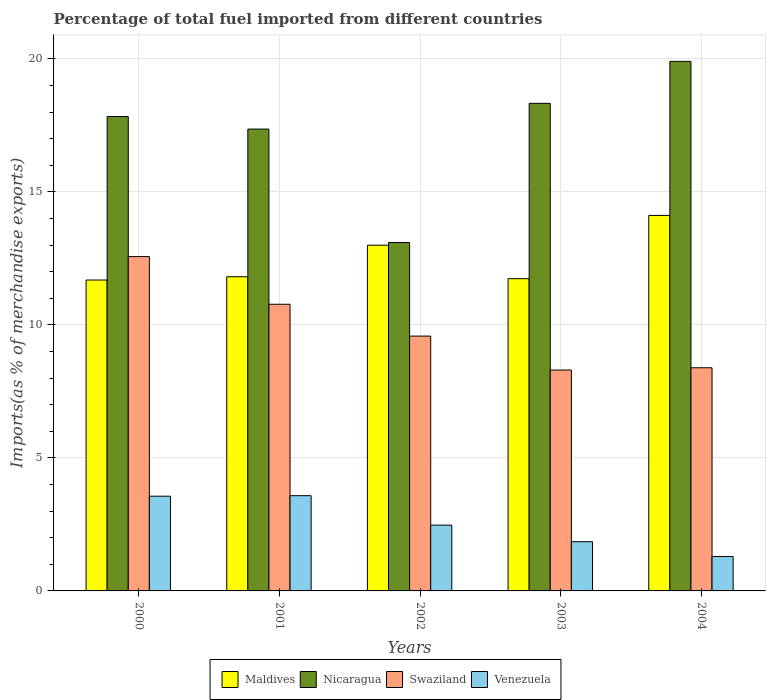How many groups of bars are there?
Your answer should be compact. 5. Are the number of bars per tick equal to the number of legend labels?
Provide a succinct answer. Yes. What is the label of the 1st group of bars from the left?
Your response must be concise. 2000. In how many cases, is the number of bars for a given year not equal to the number of legend labels?
Make the answer very short. 0. What is the percentage of imports to different countries in Nicaragua in 2003?
Offer a terse response. 18.33. Across all years, what is the maximum percentage of imports to different countries in Maldives?
Your answer should be very brief. 14.11. Across all years, what is the minimum percentage of imports to different countries in Nicaragua?
Provide a short and direct response. 13.1. In which year was the percentage of imports to different countries in Nicaragua maximum?
Offer a very short reply. 2004. In which year was the percentage of imports to different countries in Swaziland minimum?
Your answer should be compact. 2003. What is the total percentage of imports to different countries in Swaziland in the graph?
Your answer should be very brief. 49.61. What is the difference between the percentage of imports to different countries in Maldives in 2000 and that in 2001?
Keep it short and to the point. -0.12. What is the difference between the percentage of imports to different countries in Nicaragua in 2000 and the percentage of imports to different countries in Venezuela in 2003?
Make the answer very short. 15.98. What is the average percentage of imports to different countries in Venezuela per year?
Provide a succinct answer. 2.55. In the year 2000, what is the difference between the percentage of imports to different countries in Maldives and percentage of imports to different countries in Nicaragua?
Provide a short and direct response. -6.14. What is the ratio of the percentage of imports to different countries in Maldives in 2000 to that in 2001?
Your answer should be very brief. 0.99. Is the percentage of imports to different countries in Nicaragua in 2001 less than that in 2002?
Your answer should be compact. No. Is the difference between the percentage of imports to different countries in Maldives in 2000 and 2001 greater than the difference between the percentage of imports to different countries in Nicaragua in 2000 and 2001?
Provide a succinct answer. No. What is the difference between the highest and the second highest percentage of imports to different countries in Venezuela?
Provide a short and direct response. 0.02. What is the difference between the highest and the lowest percentage of imports to different countries in Swaziland?
Your answer should be compact. 4.26. In how many years, is the percentage of imports to different countries in Venezuela greater than the average percentage of imports to different countries in Venezuela taken over all years?
Your answer should be compact. 2. Is the sum of the percentage of imports to different countries in Nicaragua in 2000 and 2001 greater than the maximum percentage of imports to different countries in Venezuela across all years?
Provide a succinct answer. Yes. Is it the case that in every year, the sum of the percentage of imports to different countries in Venezuela and percentage of imports to different countries in Maldives is greater than the sum of percentage of imports to different countries in Nicaragua and percentage of imports to different countries in Swaziland?
Give a very brief answer. No. What does the 4th bar from the left in 2004 represents?
Provide a short and direct response. Venezuela. What does the 4th bar from the right in 2002 represents?
Your answer should be very brief. Maldives. What is the difference between two consecutive major ticks on the Y-axis?
Offer a very short reply. 5. Are the values on the major ticks of Y-axis written in scientific E-notation?
Ensure brevity in your answer.  No. Does the graph contain any zero values?
Your response must be concise. No. How many legend labels are there?
Give a very brief answer. 4. How are the legend labels stacked?
Your response must be concise. Horizontal. What is the title of the graph?
Keep it short and to the point. Percentage of total fuel imported from different countries. What is the label or title of the X-axis?
Your answer should be compact. Years. What is the label or title of the Y-axis?
Your response must be concise. Imports(as % of merchandise exports). What is the Imports(as % of merchandise exports) of Maldives in 2000?
Make the answer very short. 11.69. What is the Imports(as % of merchandise exports) of Nicaragua in 2000?
Ensure brevity in your answer.  17.83. What is the Imports(as % of merchandise exports) of Swaziland in 2000?
Make the answer very short. 12.57. What is the Imports(as % of merchandise exports) in Venezuela in 2000?
Provide a short and direct response. 3.56. What is the Imports(as % of merchandise exports) in Maldives in 2001?
Make the answer very short. 11.81. What is the Imports(as % of merchandise exports) in Nicaragua in 2001?
Your answer should be very brief. 17.36. What is the Imports(as % of merchandise exports) of Swaziland in 2001?
Provide a succinct answer. 10.78. What is the Imports(as % of merchandise exports) of Venezuela in 2001?
Ensure brevity in your answer.  3.58. What is the Imports(as % of merchandise exports) of Maldives in 2002?
Keep it short and to the point. 13. What is the Imports(as % of merchandise exports) of Nicaragua in 2002?
Provide a succinct answer. 13.1. What is the Imports(as % of merchandise exports) in Swaziland in 2002?
Provide a short and direct response. 9.58. What is the Imports(as % of merchandise exports) in Venezuela in 2002?
Your answer should be very brief. 2.47. What is the Imports(as % of merchandise exports) in Maldives in 2003?
Provide a succinct answer. 11.74. What is the Imports(as % of merchandise exports) in Nicaragua in 2003?
Make the answer very short. 18.33. What is the Imports(as % of merchandise exports) in Swaziland in 2003?
Your answer should be very brief. 8.3. What is the Imports(as % of merchandise exports) of Venezuela in 2003?
Keep it short and to the point. 1.85. What is the Imports(as % of merchandise exports) in Maldives in 2004?
Your response must be concise. 14.11. What is the Imports(as % of merchandise exports) of Nicaragua in 2004?
Make the answer very short. 19.91. What is the Imports(as % of merchandise exports) in Swaziland in 2004?
Your answer should be very brief. 8.39. What is the Imports(as % of merchandise exports) in Venezuela in 2004?
Ensure brevity in your answer.  1.29. Across all years, what is the maximum Imports(as % of merchandise exports) in Maldives?
Your response must be concise. 14.11. Across all years, what is the maximum Imports(as % of merchandise exports) in Nicaragua?
Make the answer very short. 19.91. Across all years, what is the maximum Imports(as % of merchandise exports) in Swaziland?
Give a very brief answer. 12.57. Across all years, what is the maximum Imports(as % of merchandise exports) of Venezuela?
Make the answer very short. 3.58. Across all years, what is the minimum Imports(as % of merchandise exports) in Maldives?
Keep it short and to the point. 11.69. Across all years, what is the minimum Imports(as % of merchandise exports) of Nicaragua?
Ensure brevity in your answer.  13.1. Across all years, what is the minimum Imports(as % of merchandise exports) of Swaziland?
Offer a terse response. 8.3. Across all years, what is the minimum Imports(as % of merchandise exports) of Venezuela?
Make the answer very short. 1.29. What is the total Imports(as % of merchandise exports) in Maldives in the graph?
Your answer should be very brief. 62.34. What is the total Imports(as % of merchandise exports) of Nicaragua in the graph?
Your answer should be compact. 86.52. What is the total Imports(as % of merchandise exports) of Swaziland in the graph?
Your answer should be very brief. 49.61. What is the total Imports(as % of merchandise exports) of Venezuela in the graph?
Provide a succinct answer. 12.76. What is the difference between the Imports(as % of merchandise exports) in Maldives in 2000 and that in 2001?
Your answer should be compact. -0.12. What is the difference between the Imports(as % of merchandise exports) in Nicaragua in 2000 and that in 2001?
Ensure brevity in your answer.  0.47. What is the difference between the Imports(as % of merchandise exports) of Swaziland in 2000 and that in 2001?
Ensure brevity in your answer.  1.79. What is the difference between the Imports(as % of merchandise exports) of Venezuela in 2000 and that in 2001?
Keep it short and to the point. -0.02. What is the difference between the Imports(as % of merchandise exports) of Maldives in 2000 and that in 2002?
Provide a short and direct response. -1.31. What is the difference between the Imports(as % of merchandise exports) in Nicaragua in 2000 and that in 2002?
Your answer should be very brief. 4.73. What is the difference between the Imports(as % of merchandise exports) of Swaziland in 2000 and that in 2002?
Offer a terse response. 2.99. What is the difference between the Imports(as % of merchandise exports) of Venezuela in 2000 and that in 2002?
Give a very brief answer. 1.09. What is the difference between the Imports(as % of merchandise exports) of Maldives in 2000 and that in 2003?
Provide a succinct answer. -0.05. What is the difference between the Imports(as % of merchandise exports) of Nicaragua in 2000 and that in 2003?
Ensure brevity in your answer.  -0.5. What is the difference between the Imports(as % of merchandise exports) in Swaziland in 2000 and that in 2003?
Offer a terse response. 4.26. What is the difference between the Imports(as % of merchandise exports) of Venezuela in 2000 and that in 2003?
Provide a short and direct response. 1.71. What is the difference between the Imports(as % of merchandise exports) in Maldives in 2000 and that in 2004?
Give a very brief answer. -2.43. What is the difference between the Imports(as % of merchandise exports) of Nicaragua in 2000 and that in 2004?
Ensure brevity in your answer.  -2.08. What is the difference between the Imports(as % of merchandise exports) in Swaziland in 2000 and that in 2004?
Make the answer very short. 4.18. What is the difference between the Imports(as % of merchandise exports) of Venezuela in 2000 and that in 2004?
Your response must be concise. 2.27. What is the difference between the Imports(as % of merchandise exports) of Maldives in 2001 and that in 2002?
Your response must be concise. -1.19. What is the difference between the Imports(as % of merchandise exports) in Nicaragua in 2001 and that in 2002?
Your answer should be compact. 4.26. What is the difference between the Imports(as % of merchandise exports) in Swaziland in 2001 and that in 2002?
Ensure brevity in your answer.  1.2. What is the difference between the Imports(as % of merchandise exports) of Venezuela in 2001 and that in 2002?
Your answer should be very brief. 1.11. What is the difference between the Imports(as % of merchandise exports) in Maldives in 2001 and that in 2003?
Provide a short and direct response. 0.07. What is the difference between the Imports(as % of merchandise exports) of Nicaragua in 2001 and that in 2003?
Your answer should be compact. -0.97. What is the difference between the Imports(as % of merchandise exports) in Swaziland in 2001 and that in 2003?
Give a very brief answer. 2.47. What is the difference between the Imports(as % of merchandise exports) in Venezuela in 2001 and that in 2003?
Offer a terse response. 1.73. What is the difference between the Imports(as % of merchandise exports) of Maldives in 2001 and that in 2004?
Provide a short and direct response. -2.3. What is the difference between the Imports(as % of merchandise exports) in Nicaragua in 2001 and that in 2004?
Provide a succinct answer. -2.55. What is the difference between the Imports(as % of merchandise exports) of Swaziland in 2001 and that in 2004?
Make the answer very short. 2.39. What is the difference between the Imports(as % of merchandise exports) of Venezuela in 2001 and that in 2004?
Your answer should be very brief. 2.29. What is the difference between the Imports(as % of merchandise exports) of Maldives in 2002 and that in 2003?
Ensure brevity in your answer.  1.26. What is the difference between the Imports(as % of merchandise exports) in Nicaragua in 2002 and that in 2003?
Your answer should be compact. -5.23. What is the difference between the Imports(as % of merchandise exports) of Swaziland in 2002 and that in 2003?
Make the answer very short. 1.28. What is the difference between the Imports(as % of merchandise exports) in Venezuela in 2002 and that in 2003?
Give a very brief answer. 0.62. What is the difference between the Imports(as % of merchandise exports) in Maldives in 2002 and that in 2004?
Offer a terse response. -1.12. What is the difference between the Imports(as % of merchandise exports) of Nicaragua in 2002 and that in 2004?
Keep it short and to the point. -6.81. What is the difference between the Imports(as % of merchandise exports) of Swaziland in 2002 and that in 2004?
Your answer should be very brief. 1.19. What is the difference between the Imports(as % of merchandise exports) of Venezuela in 2002 and that in 2004?
Ensure brevity in your answer.  1.18. What is the difference between the Imports(as % of merchandise exports) in Maldives in 2003 and that in 2004?
Ensure brevity in your answer.  -2.38. What is the difference between the Imports(as % of merchandise exports) in Nicaragua in 2003 and that in 2004?
Your answer should be compact. -1.58. What is the difference between the Imports(as % of merchandise exports) of Swaziland in 2003 and that in 2004?
Offer a terse response. -0.09. What is the difference between the Imports(as % of merchandise exports) in Venezuela in 2003 and that in 2004?
Make the answer very short. 0.56. What is the difference between the Imports(as % of merchandise exports) of Maldives in 2000 and the Imports(as % of merchandise exports) of Nicaragua in 2001?
Keep it short and to the point. -5.67. What is the difference between the Imports(as % of merchandise exports) in Maldives in 2000 and the Imports(as % of merchandise exports) in Swaziland in 2001?
Provide a succinct answer. 0.91. What is the difference between the Imports(as % of merchandise exports) in Maldives in 2000 and the Imports(as % of merchandise exports) in Venezuela in 2001?
Your answer should be compact. 8.11. What is the difference between the Imports(as % of merchandise exports) in Nicaragua in 2000 and the Imports(as % of merchandise exports) in Swaziland in 2001?
Give a very brief answer. 7.06. What is the difference between the Imports(as % of merchandise exports) in Nicaragua in 2000 and the Imports(as % of merchandise exports) in Venezuela in 2001?
Provide a succinct answer. 14.25. What is the difference between the Imports(as % of merchandise exports) of Swaziland in 2000 and the Imports(as % of merchandise exports) of Venezuela in 2001?
Provide a short and direct response. 8.99. What is the difference between the Imports(as % of merchandise exports) of Maldives in 2000 and the Imports(as % of merchandise exports) of Nicaragua in 2002?
Keep it short and to the point. -1.41. What is the difference between the Imports(as % of merchandise exports) of Maldives in 2000 and the Imports(as % of merchandise exports) of Swaziland in 2002?
Your answer should be very brief. 2.11. What is the difference between the Imports(as % of merchandise exports) of Maldives in 2000 and the Imports(as % of merchandise exports) of Venezuela in 2002?
Your answer should be compact. 9.21. What is the difference between the Imports(as % of merchandise exports) in Nicaragua in 2000 and the Imports(as % of merchandise exports) in Swaziland in 2002?
Give a very brief answer. 8.25. What is the difference between the Imports(as % of merchandise exports) in Nicaragua in 2000 and the Imports(as % of merchandise exports) in Venezuela in 2002?
Make the answer very short. 15.36. What is the difference between the Imports(as % of merchandise exports) of Swaziland in 2000 and the Imports(as % of merchandise exports) of Venezuela in 2002?
Your response must be concise. 10.09. What is the difference between the Imports(as % of merchandise exports) in Maldives in 2000 and the Imports(as % of merchandise exports) in Nicaragua in 2003?
Make the answer very short. -6.64. What is the difference between the Imports(as % of merchandise exports) in Maldives in 2000 and the Imports(as % of merchandise exports) in Swaziland in 2003?
Provide a short and direct response. 3.38. What is the difference between the Imports(as % of merchandise exports) of Maldives in 2000 and the Imports(as % of merchandise exports) of Venezuela in 2003?
Provide a succinct answer. 9.84. What is the difference between the Imports(as % of merchandise exports) in Nicaragua in 2000 and the Imports(as % of merchandise exports) in Swaziland in 2003?
Offer a terse response. 9.53. What is the difference between the Imports(as % of merchandise exports) of Nicaragua in 2000 and the Imports(as % of merchandise exports) of Venezuela in 2003?
Make the answer very short. 15.98. What is the difference between the Imports(as % of merchandise exports) in Swaziland in 2000 and the Imports(as % of merchandise exports) in Venezuela in 2003?
Offer a very short reply. 10.72. What is the difference between the Imports(as % of merchandise exports) of Maldives in 2000 and the Imports(as % of merchandise exports) of Nicaragua in 2004?
Your answer should be very brief. -8.22. What is the difference between the Imports(as % of merchandise exports) of Maldives in 2000 and the Imports(as % of merchandise exports) of Swaziland in 2004?
Make the answer very short. 3.3. What is the difference between the Imports(as % of merchandise exports) in Maldives in 2000 and the Imports(as % of merchandise exports) in Venezuela in 2004?
Provide a short and direct response. 10.39. What is the difference between the Imports(as % of merchandise exports) in Nicaragua in 2000 and the Imports(as % of merchandise exports) in Swaziland in 2004?
Offer a very short reply. 9.44. What is the difference between the Imports(as % of merchandise exports) of Nicaragua in 2000 and the Imports(as % of merchandise exports) of Venezuela in 2004?
Ensure brevity in your answer.  16.54. What is the difference between the Imports(as % of merchandise exports) of Swaziland in 2000 and the Imports(as % of merchandise exports) of Venezuela in 2004?
Keep it short and to the point. 11.27. What is the difference between the Imports(as % of merchandise exports) of Maldives in 2001 and the Imports(as % of merchandise exports) of Nicaragua in 2002?
Give a very brief answer. -1.29. What is the difference between the Imports(as % of merchandise exports) in Maldives in 2001 and the Imports(as % of merchandise exports) in Swaziland in 2002?
Keep it short and to the point. 2.23. What is the difference between the Imports(as % of merchandise exports) in Maldives in 2001 and the Imports(as % of merchandise exports) in Venezuela in 2002?
Ensure brevity in your answer.  9.34. What is the difference between the Imports(as % of merchandise exports) in Nicaragua in 2001 and the Imports(as % of merchandise exports) in Swaziland in 2002?
Provide a succinct answer. 7.78. What is the difference between the Imports(as % of merchandise exports) of Nicaragua in 2001 and the Imports(as % of merchandise exports) of Venezuela in 2002?
Your response must be concise. 14.89. What is the difference between the Imports(as % of merchandise exports) of Swaziland in 2001 and the Imports(as % of merchandise exports) of Venezuela in 2002?
Keep it short and to the point. 8.3. What is the difference between the Imports(as % of merchandise exports) in Maldives in 2001 and the Imports(as % of merchandise exports) in Nicaragua in 2003?
Offer a very short reply. -6.52. What is the difference between the Imports(as % of merchandise exports) in Maldives in 2001 and the Imports(as % of merchandise exports) in Swaziland in 2003?
Keep it short and to the point. 3.51. What is the difference between the Imports(as % of merchandise exports) of Maldives in 2001 and the Imports(as % of merchandise exports) of Venezuela in 2003?
Your answer should be compact. 9.96. What is the difference between the Imports(as % of merchandise exports) in Nicaragua in 2001 and the Imports(as % of merchandise exports) in Swaziland in 2003?
Keep it short and to the point. 9.06. What is the difference between the Imports(as % of merchandise exports) of Nicaragua in 2001 and the Imports(as % of merchandise exports) of Venezuela in 2003?
Your answer should be compact. 15.51. What is the difference between the Imports(as % of merchandise exports) in Swaziland in 2001 and the Imports(as % of merchandise exports) in Venezuela in 2003?
Your response must be concise. 8.93. What is the difference between the Imports(as % of merchandise exports) of Maldives in 2001 and the Imports(as % of merchandise exports) of Nicaragua in 2004?
Ensure brevity in your answer.  -8.1. What is the difference between the Imports(as % of merchandise exports) in Maldives in 2001 and the Imports(as % of merchandise exports) in Swaziland in 2004?
Offer a very short reply. 3.42. What is the difference between the Imports(as % of merchandise exports) in Maldives in 2001 and the Imports(as % of merchandise exports) in Venezuela in 2004?
Ensure brevity in your answer.  10.52. What is the difference between the Imports(as % of merchandise exports) of Nicaragua in 2001 and the Imports(as % of merchandise exports) of Swaziland in 2004?
Provide a short and direct response. 8.97. What is the difference between the Imports(as % of merchandise exports) in Nicaragua in 2001 and the Imports(as % of merchandise exports) in Venezuela in 2004?
Provide a succinct answer. 16.07. What is the difference between the Imports(as % of merchandise exports) in Swaziland in 2001 and the Imports(as % of merchandise exports) in Venezuela in 2004?
Make the answer very short. 9.48. What is the difference between the Imports(as % of merchandise exports) in Maldives in 2002 and the Imports(as % of merchandise exports) in Nicaragua in 2003?
Your response must be concise. -5.33. What is the difference between the Imports(as % of merchandise exports) of Maldives in 2002 and the Imports(as % of merchandise exports) of Swaziland in 2003?
Keep it short and to the point. 4.69. What is the difference between the Imports(as % of merchandise exports) of Maldives in 2002 and the Imports(as % of merchandise exports) of Venezuela in 2003?
Offer a terse response. 11.15. What is the difference between the Imports(as % of merchandise exports) in Nicaragua in 2002 and the Imports(as % of merchandise exports) in Swaziland in 2003?
Make the answer very short. 4.79. What is the difference between the Imports(as % of merchandise exports) in Nicaragua in 2002 and the Imports(as % of merchandise exports) in Venezuela in 2003?
Keep it short and to the point. 11.25. What is the difference between the Imports(as % of merchandise exports) in Swaziland in 2002 and the Imports(as % of merchandise exports) in Venezuela in 2003?
Keep it short and to the point. 7.73. What is the difference between the Imports(as % of merchandise exports) of Maldives in 2002 and the Imports(as % of merchandise exports) of Nicaragua in 2004?
Provide a succinct answer. -6.91. What is the difference between the Imports(as % of merchandise exports) in Maldives in 2002 and the Imports(as % of merchandise exports) in Swaziland in 2004?
Ensure brevity in your answer.  4.61. What is the difference between the Imports(as % of merchandise exports) in Maldives in 2002 and the Imports(as % of merchandise exports) in Venezuela in 2004?
Provide a succinct answer. 11.7. What is the difference between the Imports(as % of merchandise exports) of Nicaragua in 2002 and the Imports(as % of merchandise exports) of Swaziland in 2004?
Your response must be concise. 4.71. What is the difference between the Imports(as % of merchandise exports) in Nicaragua in 2002 and the Imports(as % of merchandise exports) in Venezuela in 2004?
Offer a terse response. 11.8. What is the difference between the Imports(as % of merchandise exports) of Swaziland in 2002 and the Imports(as % of merchandise exports) of Venezuela in 2004?
Provide a short and direct response. 8.29. What is the difference between the Imports(as % of merchandise exports) of Maldives in 2003 and the Imports(as % of merchandise exports) of Nicaragua in 2004?
Your answer should be very brief. -8.17. What is the difference between the Imports(as % of merchandise exports) in Maldives in 2003 and the Imports(as % of merchandise exports) in Swaziland in 2004?
Provide a succinct answer. 3.35. What is the difference between the Imports(as % of merchandise exports) of Maldives in 2003 and the Imports(as % of merchandise exports) of Venezuela in 2004?
Keep it short and to the point. 10.44. What is the difference between the Imports(as % of merchandise exports) of Nicaragua in 2003 and the Imports(as % of merchandise exports) of Swaziland in 2004?
Provide a short and direct response. 9.94. What is the difference between the Imports(as % of merchandise exports) of Nicaragua in 2003 and the Imports(as % of merchandise exports) of Venezuela in 2004?
Keep it short and to the point. 17.03. What is the difference between the Imports(as % of merchandise exports) of Swaziland in 2003 and the Imports(as % of merchandise exports) of Venezuela in 2004?
Your response must be concise. 7.01. What is the average Imports(as % of merchandise exports) in Maldives per year?
Your response must be concise. 12.47. What is the average Imports(as % of merchandise exports) of Nicaragua per year?
Your answer should be compact. 17.3. What is the average Imports(as % of merchandise exports) of Swaziland per year?
Offer a terse response. 9.92. What is the average Imports(as % of merchandise exports) in Venezuela per year?
Offer a very short reply. 2.55. In the year 2000, what is the difference between the Imports(as % of merchandise exports) of Maldives and Imports(as % of merchandise exports) of Nicaragua?
Make the answer very short. -6.14. In the year 2000, what is the difference between the Imports(as % of merchandise exports) of Maldives and Imports(as % of merchandise exports) of Swaziland?
Your answer should be compact. -0.88. In the year 2000, what is the difference between the Imports(as % of merchandise exports) in Maldives and Imports(as % of merchandise exports) in Venezuela?
Provide a short and direct response. 8.13. In the year 2000, what is the difference between the Imports(as % of merchandise exports) of Nicaragua and Imports(as % of merchandise exports) of Swaziland?
Offer a very short reply. 5.26. In the year 2000, what is the difference between the Imports(as % of merchandise exports) in Nicaragua and Imports(as % of merchandise exports) in Venezuela?
Your answer should be very brief. 14.27. In the year 2000, what is the difference between the Imports(as % of merchandise exports) in Swaziland and Imports(as % of merchandise exports) in Venezuela?
Offer a very short reply. 9.01. In the year 2001, what is the difference between the Imports(as % of merchandise exports) in Maldives and Imports(as % of merchandise exports) in Nicaragua?
Provide a succinct answer. -5.55. In the year 2001, what is the difference between the Imports(as % of merchandise exports) of Maldives and Imports(as % of merchandise exports) of Swaziland?
Offer a terse response. 1.03. In the year 2001, what is the difference between the Imports(as % of merchandise exports) of Maldives and Imports(as % of merchandise exports) of Venezuela?
Provide a succinct answer. 8.23. In the year 2001, what is the difference between the Imports(as % of merchandise exports) of Nicaragua and Imports(as % of merchandise exports) of Swaziland?
Keep it short and to the point. 6.58. In the year 2001, what is the difference between the Imports(as % of merchandise exports) of Nicaragua and Imports(as % of merchandise exports) of Venezuela?
Provide a short and direct response. 13.78. In the year 2001, what is the difference between the Imports(as % of merchandise exports) of Swaziland and Imports(as % of merchandise exports) of Venezuela?
Give a very brief answer. 7.2. In the year 2002, what is the difference between the Imports(as % of merchandise exports) of Maldives and Imports(as % of merchandise exports) of Nicaragua?
Your answer should be compact. -0.1. In the year 2002, what is the difference between the Imports(as % of merchandise exports) of Maldives and Imports(as % of merchandise exports) of Swaziland?
Make the answer very short. 3.42. In the year 2002, what is the difference between the Imports(as % of merchandise exports) in Maldives and Imports(as % of merchandise exports) in Venezuela?
Your answer should be very brief. 10.52. In the year 2002, what is the difference between the Imports(as % of merchandise exports) in Nicaragua and Imports(as % of merchandise exports) in Swaziland?
Provide a succinct answer. 3.52. In the year 2002, what is the difference between the Imports(as % of merchandise exports) in Nicaragua and Imports(as % of merchandise exports) in Venezuela?
Provide a succinct answer. 10.62. In the year 2002, what is the difference between the Imports(as % of merchandise exports) of Swaziland and Imports(as % of merchandise exports) of Venezuela?
Ensure brevity in your answer.  7.11. In the year 2003, what is the difference between the Imports(as % of merchandise exports) in Maldives and Imports(as % of merchandise exports) in Nicaragua?
Make the answer very short. -6.59. In the year 2003, what is the difference between the Imports(as % of merchandise exports) in Maldives and Imports(as % of merchandise exports) in Swaziland?
Give a very brief answer. 3.43. In the year 2003, what is the difference between the Imports(as % of merchandise exports) of Maldives and Imports(as % of merchandise exports) of Venezuela?
Provide a short and direct response. 9.89. In the year 2003, what is the difference between the Imports(as % of merchandise exports) of Nicaragua and Imports(as % of merchandise exports) of Swaziland?
Provide a succinct answer. 10.02. In the year 2003, what is the difference between the Imports(as % of merchandise exports) in Nicaragua and Imports(as % of merchandise exports) in Venezuela?
Give a very brief answer. 16.48. In the year 2003, what is the difference between the Imports(as % of merchandise exports) in Swaziland and Imports(as % of merchandise exports) in Venezuela?
Your response must be concise. 6.45. In the year 2004, what is the difference between the Imports(as % of merchandise exports) of Maldives and Imports(as % of merchandise exports) of Nicaragua?
Make the answer very short. -5.79. In the year 2004, what is the difference between the Imports(as % of merchandise exports) in Maldives and Imports(as % of merchandise exports) in Swaziland?
Make the answer very short. 5.73. In the year 2004, what is the difference between the Imports(as % of merchandise exports) of Maldives and Imports(as % of merchandise exports) of Venezuela?
Your answer should be compact. 12.82. In the year 2004, what is the difference between the Imports(as % of merchandise exports) of Nicaragua and Imports(as % of merchandise exports) of Swaziland?
Offer a very short reply. 11.52. In the year 2004, what is the difference between the Imports(as % of merchandise exports) in Nicaragua and Imports(as % of merchandise exports) in Venezuela?
Your response must be concise. 18.61. In the year 2004, what is the difference between the Imports(as % of merchandise exports) in Swaziland and Imports(as % of merchandise exports) in Venezuela?
Keep it short and to the point. 7.1. What is the ratio of the Imports(as % of merchandise exports) of Nicaragua in 2000 to that in 2001?
Provide a succinct answer. 1.03. What is the ratio of the Imports(as % of merchandise exports) in Swaziland in 2000 to that in 2001?
Provide a short and direct response. 1.17. What is the ratio of the Imports(as % of merchandise exports) in Maldives in 2000 to that in 2002?
Offer a terse response. 0.9. What is the ratio of the Imports(as % of merchandise exports) in Nicaragua in 2000 to that in 2002?
Offer a very short reply. 1.36. What is the ratio of the Imports(as % of merchandise exports) of Swaziland in 2000 to that in 2002?
Ensure brevity in your answer.  1.31. What is the ratio of the Imports(as % of merchandise exports) in Venezuela in 2000 to that in 2002?
Your response must be concise. 1.44. What is the ratio of the Imports(as % of merchandise exports) in Nicaragua in 2000 to that in 2003?
Your answer should be compact. 0.97. What is the ratio of the Imports(as % of merchandise exports) of Swaziland in 2000 to that in 2003?
Provide a succinct answer. 1.51. What is the ratio of the Imports(as % of merchandise exports) in Venezuela in 2000 to that in 2003?
Provide a succinct answer. 1.93. What is the ratio of the Imports(as % of merchandise exports) in Maldives in 2000 to that in 2004?
Offer a terse response. 0.83. What is the ratio of the Imports(as % of merchandise exports) of Nicaragua in 2000 to that in 2004?
Keep it short and to the point. 0.9. What is the ratio of the Imports(as % of merchandise exports) in Swaziland in 2000 to that in 2004?
Your response must be concise. 1.5. What is the ratio of the Imports(as % of merchandise exports) in Venezuela in 2000 to that in 2004?
Your answer should be compact. 2.75. What is the ratio of the Imports(as % of merchandise exports) in Maldives in 2001 to that in 2002?
Provide a succinct answer. 0.91. What is the ratio of the Imports(as % of merchandise exports) of Nicaragua in 2001 to that in 2002?
Provide a short and direct response. 1.33. What is the ratio of the Imports(as % of merchandise exports) of Venezuela in 2001 to that in 2002?
Ensure brevity in your answer.  1.45. What is the ratio of the Imports(as % of merchandise exports) in Maldives in 2001 to that in 2003?
Give a very brief answer. 1.01. What is the ratio of the Imports(as % of merchandise exports) of Nicaragua in 2001 to that in 2003?
Your answer should be very brief. 0.95. What is the ratio of the Imports(as % of merchandise exports) in Swaziland in 2001 to that in 2003?
Give a very brief answer. 1.3. What is the ratio of the Imports(as % of merchandise exports) in Venezuela in 2001 to that in 2003?
Your response must be concise. 1.94. What is the ratio of the Imports(as % of merchandise exports) in Maldives in 2001 to that in 2004?
Make the answer very short. 0.84. What is the ratio of the Imports(as % of merchandise exports) in Nicaragua in 2001 to that in 2004?
Your answer should be very brief. 0.87. What is the ratio of the Imports(as % of merchandise exports) in Swaziland in 2001 to that in 2004?
Your answer should be compact. 1.28. What is the ratio of the Imports(as % of merchandise exports) in Venezuela in 2001 to that in 2004?
Ensure brevity in your answer.  2.77. What is the ratio of the Imports(as % of merchandise exports) in Maldives in 2002 to that in 2003?
Ensure brevity in your answer.  1.11. What is the ratio of the Imports(as % of merchandise exports) in Nicaragua in 2002 to that in 2003?
Provide a succinct answer. 0.71. What is the ratio of the Imports(as % of merchandise exports) of Swaziland in 2002 to that in 2003?
Make the answer very short. 1.15. What is the ratio of the Imports(as % of merchandise exports) of Venezuela in 2002 to that in 2003?
Your answer should be very brief. 1.34. What is the ratio of the Imports(as % of merchandise exports) of Maldives in 2002 to that in 2004?
Your answer should be very brief. 0.92. What is the ratio of the Imports(as % of merchandise exports) in Nicaragua in 2002 to that in 2004?
Make the answer very short. 0.66. What is the ratio of the Imports(as % of merchandise exports) of Swaziland in 2002 to that in 2004?
Keep it short and to the point. 1.14. What is the ratio of the Imports(as % of merchandise exports) in Venezuela in 2002 to that in 2004?
Offer a very short reply. 1.91. What is the ratio of the Imports(as % of merchandise exports) of Maldives in 2003 to that in 2004?
Your answer should be very brief. 0.83. What is the ratio of the Imports(as % of merchandise exports) in Nicaragua in 2003 to that in 2004?
Your response must be concise. 0.92. What is the ratio of the Imports(as % of merchandise exports) in Venezuela in 2003 to that in 2004?
Your response must be concise. 1.43. What is the difference between the highest and the second highest Imports(as % of merchandise exports) in Maldives?
Provide a short and direct response. 1.12. What is the difference between the highest and the second highest Imports(as % of merchandise exports) in Nicaragua?
Make the answer very short. 1.58. What is the difference between the highest and the second highest Imports(as % of merchandise exports) in Swaziland?
Offer a terse response. 1.79. What is the difference between the highest and the second highest Imports(as % of merchandise exports) of Venezuela?
Your answer should be compact. 0.02. What is the difference between the highest and the lowest Imports(as % of merchandise exports) in Maldives?
Make the answer very short. 2.43. What is the difference between the highest and the lowest Imports(as % of merchandise exports) of Nicaragua?
Provide a short and direct response. 6.81. What is the difference between the highest and the lowest Imports(as % of merchandise exports) of Swaziland?
Ensure brevity in your answer.  4.26. What is the difference between the highest and the lowest Imports(as % of merchandise exports) of Venezuela?
Offer a terse response. 2.29. 